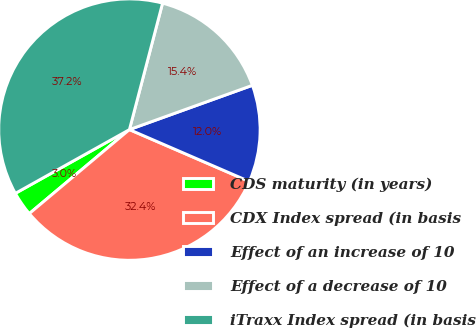Convert chart. <chart><loc_0><loc_0><loc_500><loc_500><pie_chart><fcel>CDS maturity (in years)<fcel>CDX Index spread (in basis<fcel>Effect of an increase of 10<fcel>Effect of a decrease of 10<fcel>iTraxx Index spread (in basis<nl><fcel>3.0%<fcel>32.39%<fcel>12.0%<fcel>15.42%<fcel>37.19%<nl></chart> 